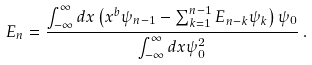<formula> <loc_0><loc_0><loc_500><loc_500>E _ { n } = \frac { \int _ { - \infty } ^ { \infty } d x \left ( x ^ { b } \psi _ { n - 1 } - \sum _ { k = 1 } ^ { n - 1 } E _ { n - k } \psi _ { k } \right ) \psi _ { 0 } } { \int _ { - \infty } ^ { \infty } d x \psi _ { 0 } ^ { 2 } } \, .</formula> 